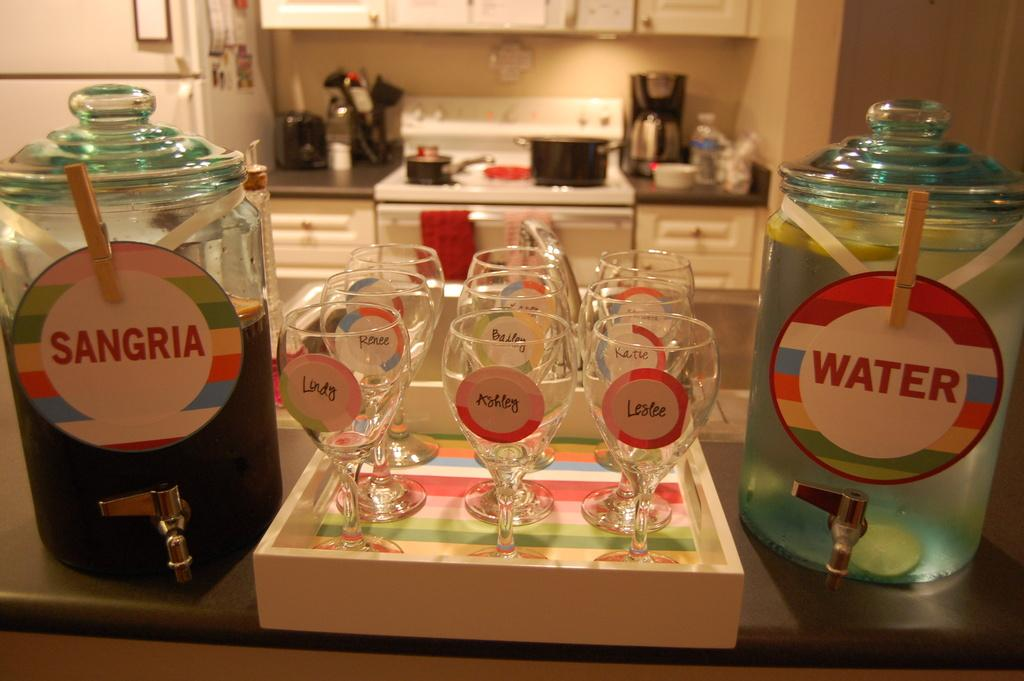What objects are present on the sides of the image? There are two glass jars on either side. What is located between the jars? There are glasses in between the jars. What can be seen in the background of the image? There are cooking utensils in the background. What type of blood is visible in the image? There is no blood visible in the image. Can you see a baby in the image? There is no baby present in the image. 